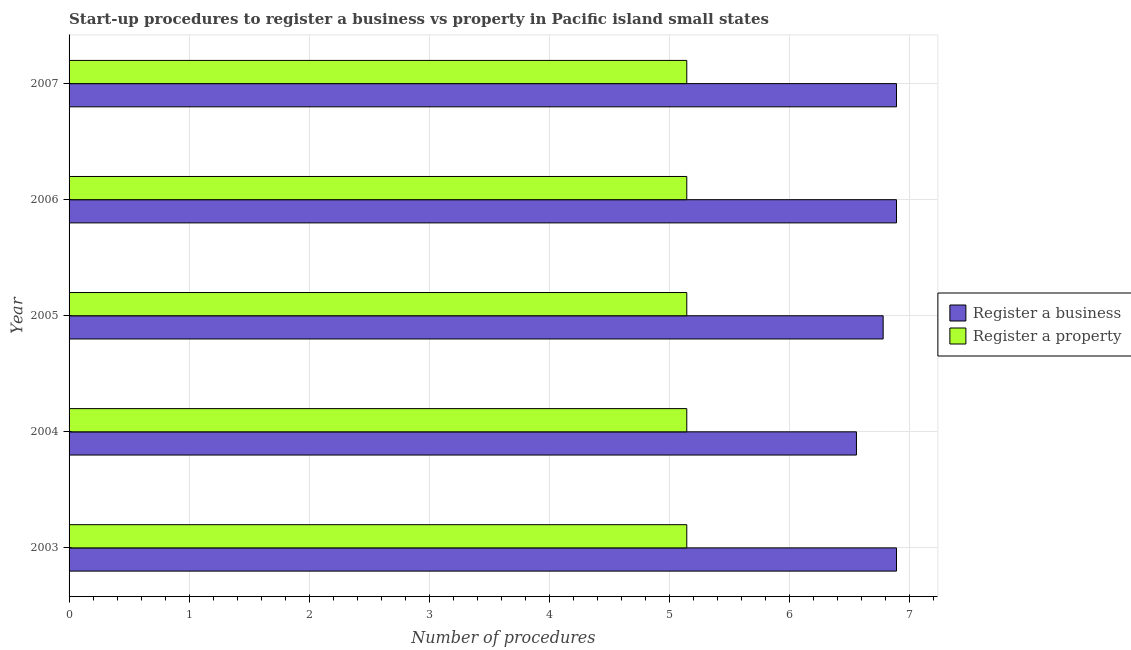How many bars are there on the 1st tick from the bottom?
Your response must be concise. 2. What is the number of procedures to register a business in 2003?
Provide a succinct answer. 6.89. Across all years, what is the maximum number of procedures to register a business?
Offer a terse response. 6.89. Across all years, what is the minimum number of procedures to register a property?
Give a very brief answer. 5.14. What is the total number of procedures to register a property in the graph?
Your answer should be very brief. 25.71. What is the difference between the number of procedures to register a property in 2005 and that in 2007?
Your answer should be compact. 0. What is the difference between the number of procedures to register a property in 2005 and the number of procedures to register a business in 2006?
Ensure brevity in your answer.  -1.75. What is the average number of procedures to register a property per year?
Your answer should be compact. 5.14. In the year 2006, what is the difference between the number of procedures to register a business and number of procedures to register a property?
Your answer should be compact. 1.75. Is the number of procedures to register a property in 2003 less than that in 2004?
Your answer should be very brief. No. Is the sum of the number of procedures to register a property in 2003 and 2007 greater than the maximum number of procedures to register a business across all years?
Keep it short and to the point. Yes. What does the 2nd bar from the top in 2006 represents?
Keep it short and to the point. Register a business. What does the 1st bar from the bottom in 2003 represents?
Offer a terse response. Register a business. How many bars are there?
Provide a succinct answer. 10. Are all the bars in the graph horizontal?
Give a very brief answer. Yes. How many legend labels are there?
Make the answer very short. 2. How are the legend labels stacked?
Offer a terse response. Vertical. What is the title of the graph?
Your answer should be compact. Start-up procedures to register a business vs property in Pacific island small states. Does "National Visitors" appear as one of the legend labels in the graph?
Keep it short and to the point. No. What is the label or title of the X-axis?
Provide a short and direct response. Number of procedures. What is the label or title of the Y-axis?
Keep it short and to the point. Year. What is the Number of procedures of Register a business in 2003?
Ensure brevity in your answer.  6.89. What is the Number of procedures in Register a property in 2003?
Keep it short and to the point. 5.14. What is the Number of procedures of Register a business in 2004?
Offer a very short reply. 6.56. What is the Number of procedures in Register a property in 2004?
Your answer should be very brief. 5.14. What is the Number of procedures of Register a business in 2005?
Your response must be concise. 6.78. What is the Number of procedures of Register a property in 2005?
Offer a terse response. 5.14. What is the Number of procedures in Register a business in 2006?
Your answer should be very brief. 6.89. What is the Number of procedures in Register a property in 2006?
Your response must be concise. 5.14. What is the Number of procedures of Register a business in 2007?
Your answer should be very brief. 6.89. What is the Number of procedures of Register a property in 2007?
Your answer should be compact. 5.14. Across all years, what is the maximum Number of procedures in Register a business?
Your answer should be compact. 6.89. Across all years, what is the maximum Number of procedures of Register a property?
Your response must be concise. 5.14. Across all years, what is the minimum Number of procedures in Register a business?
Your answer should be very brief. 6.56. Across all years, what is the minimum Number of procedures of Register a property?
Provide a succinct answer. 5.14. What is the total Number of procedures of Register a business in the graph?
Your answer should be compact. 34. What is the total Number of procedures of Register a property in the graph?
Your answer should be compact. 25.71. What is the difference between the Number of procedures of Register a property in 2003 and that in 2004?
Give a very brief answer. 0. What is the difference between the Number of procedures in Register a business in 2003 and that in 2005?
Your response must be concise. 0.11. What is the difference between the Number of procedures in Register a business in 2003 and that in 2006?
Offer a very short reply. 0. What is the difference between the Number of procedures in Register a business in 2004 and that in 2005?
Your answer should be very brief. -0.22. What is the difference between the Number of procedures of Register a business in 2004 and that in 2006?
Your response must be concise. -0.33. What is the difference between the Number of procedures in Register a property in 2004 and that in 2006?
Your answer should be compact. 0. What is the difference between the Number of procedures of Register a property in 2004 and that in 2007?
Provide a short and direct response. 0. What is the difference between the Number of procedures of Register a business in 2005 and that in 2006?
Make the answer very short. -0.11. What is the difference between the Number of procedures in Register a business in 2005 and that in 2007?
Make the answer very short. -0.11. What is the difference between the Number of procedures of Register a business in 2006 and that in 2007?
Offer a very short reply. 0. What is the difference between the Number of procedures in Register a property in 2006 and that in 2007?
Provide a succinct answer. 0. What is the difference between the Number of procedures in Register a business in 2003 and the Number of procedures in Register a property in 2004?
Your answer should be very brief. 1.75. What is the difference between the Number of procedures of Register a business in 2003 and the Number of procedures of Register a property in 2005?
Provide a short and direct response. 1.75. What is the difference between the Number of procedures in Register a business in 2003 and the Number of procedures in Register a property in 2006?
Your answer should be compact. 1.75. What is the difference between the Number of procedures in Register a business in 2003 and the Number of procedures in Register a property in 2007?
Make the answer very short. 1.75. What is the difference between the Number of procedures of Register a business in 2004 and the Number of procedures of Register a property in 2005?
Ensure brevity in your answer.  1.41. What is the difference between the Number of procedures of Register a business in 2004 and the Number of procedures of Register a property in 2006?
Keep it short and to the point. 1.41. What is the difference between the Number of procedures in Register a business in 2004 and the Number of procedures in Register a property in 2007?
Make the answer very short. 1.41. What is the difference between the Number of procedures of Register a business in 2005 and the Number of procedures of Register a property in 2006?
Provide a short and direct response. 1.63. What is the difference between the Number of procedures of Register a business in 2005 and the Number of procedures of Register a property in 2007?
Your answer should be compact. 1.63. What is the difference between the Number of procedures in Register a business in 2006 and the Number of procedures in Register a property in 2007?
Keep it short and to the point. 1.75. What is the average Number of procedures in Register a business per year?
Offer a very short reply. 6.8. What is the average Number of procedures of Register a property per year?
Your answer should be compact. 5.14. In the year 2003, what is the difference between the Number of procedures in Register a business and Number of procedures in Register a property?
Make the answer very short. 1.75. In the year 2004, what is the difference between the Number of procedures of Register a business and Number of procedures of Register a property?
Your response must be concise. 1.41. In the year 2005, what is the difference between the Number of procedures of Register a business and Number of procedures of Register a property?
Your response must be concise. 1.63. In the year 2006, what is the difference between the Number of procedures in Register a business and Number of procedures in Register a property?
Provide a succinct answer. 1.75. In the year 2007, what is the difference between the Number of procedures in Register a business and Number of procedures in Register a property?
Your answer should be compact. 1.75. What is the ratio of the Number of procedures of Register a business in 2003 to that in 2004?
Keep it short and to the point. 1.05. What is the ratio of the Number of procedures of Register a property in 2003 to that in 2004?
Your answer should be very brief. 1. What is the ratio of the Number of procedures in Register a business in 2003 to that in 2005?
Your answer should be compact. 1.02. What is the ratio of the Number of procedures of Register a business in 2003 to that in 2007?
Ensure brevity in your answer.  1. What is the ratio of the Number of procedures in Register a property in 2003 to that in 2007?
Your response must be concise. 1. What is the ratio of the Number of procedures of Register a business in 2004 to that in 2005?
Give a very brief answer. 0.97. What is the ratio of the Number of procedures in Register a property in 2004 to that in 2005?
Keep it short and to the point. 1. What is the ratio of the Number of procedures in Register a business in 2004 to that in 2006?
Make the answer very short. 0.95. What is the ratio of the Number of procedures of Register a business in 2004 to that in 2007?
Offer a very short reply. 0.95. What is the ratio of the Number of procedures in Register a business in 2005 to that in 2006?
Give a very brief answer. 0.98. What is the ratio of the Number of procedures of Register a business in 2005 to that in 2007?
Provide a short and direct response. 0.98. What is the difference between the highest and the second highest Number of procedures in Register a business?
Your answer should be very brief. 0. What is the difference between the highest and the second highest Number of procedures in Register a property?
Ensure brevity in your answer.  0. What is the difference between the highest and the lowest Number of procedures in Register a business?
Keep it short and to the point. 0.33. 